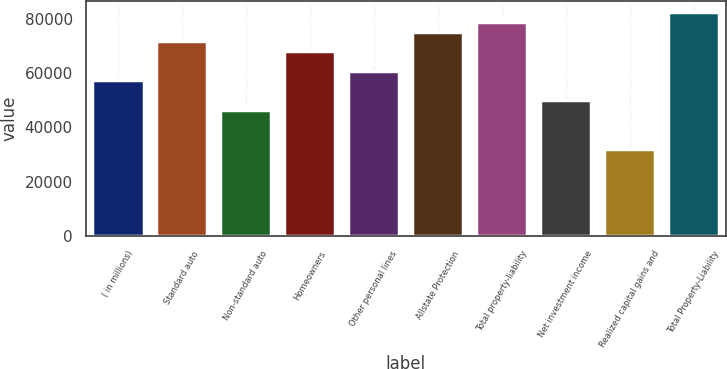Convert chart. <chart><loc_0><loc_0><loc_500><loc_500><bar_chart><fcel>( in millions)<fcel>Standard auto<fcel>Non-standard auto<fcel>Homeowners<fcel>Other personal lines<fcel>Allstate Protection<fcel>Total property-liability<fcel>Net investment income<fcel>Realized capital gains and<fcel>Total Property-Liability<nl><fcel>57267.6<fcel>71582<fcel>46531.8<fcel>68003.4<fcel>60846.2<fcel>75160.6<fcel>78739.2<fcel>50110.4<fcel>32217.4<fcel>82317.8<nl></chart> 